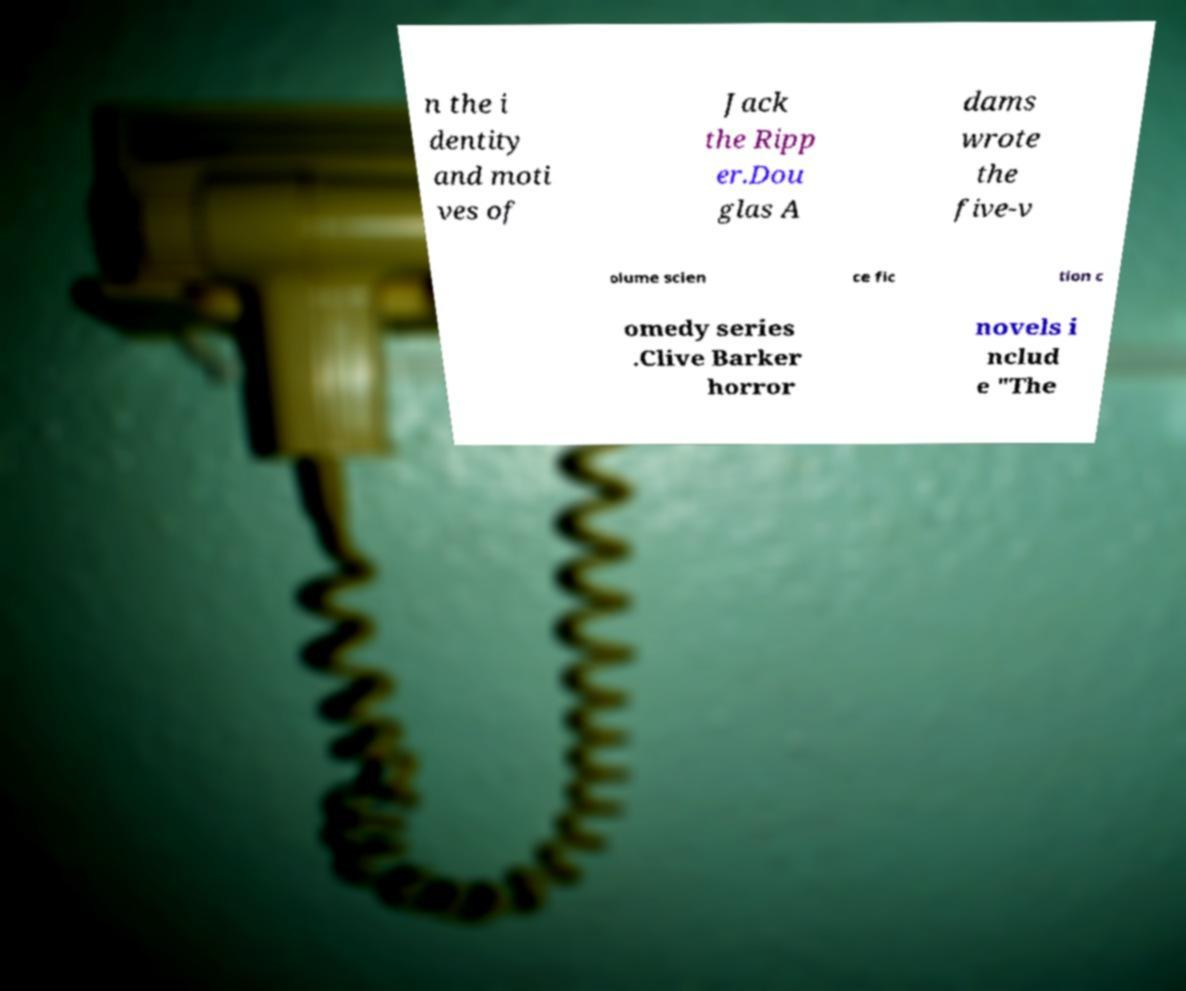Please identify and transcribe the text found in this image. n the i dentity and moti ves of Jack the Ripp er.Dou glas A dams wrote the five-v olume scien ce fic tion c omedy series .Clive Barker horror novels i nclud e "The 